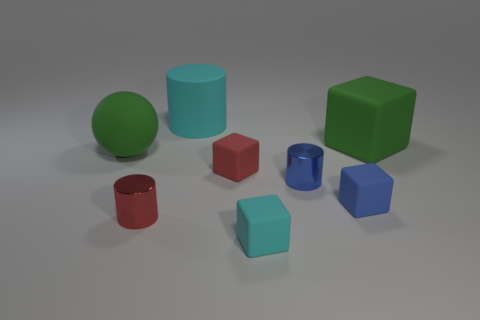Subtract all gray blocks. Subtract all green spheres. How many blocks are left? 4 Add 1 cyan matte things. How many objects exist? 9 Subtract all cylinders. How many objects are left? 5 Subtract 0 green cylinders. How many objects are left? 8 Subtract all large green matte cylinders. Subtract all green balls. How many objects are left? 7 Add 6 red shiny cylinders. How many red shiny cylinders are left? 7 Add 5 red cylinders. How many red cylinders exist? 6 